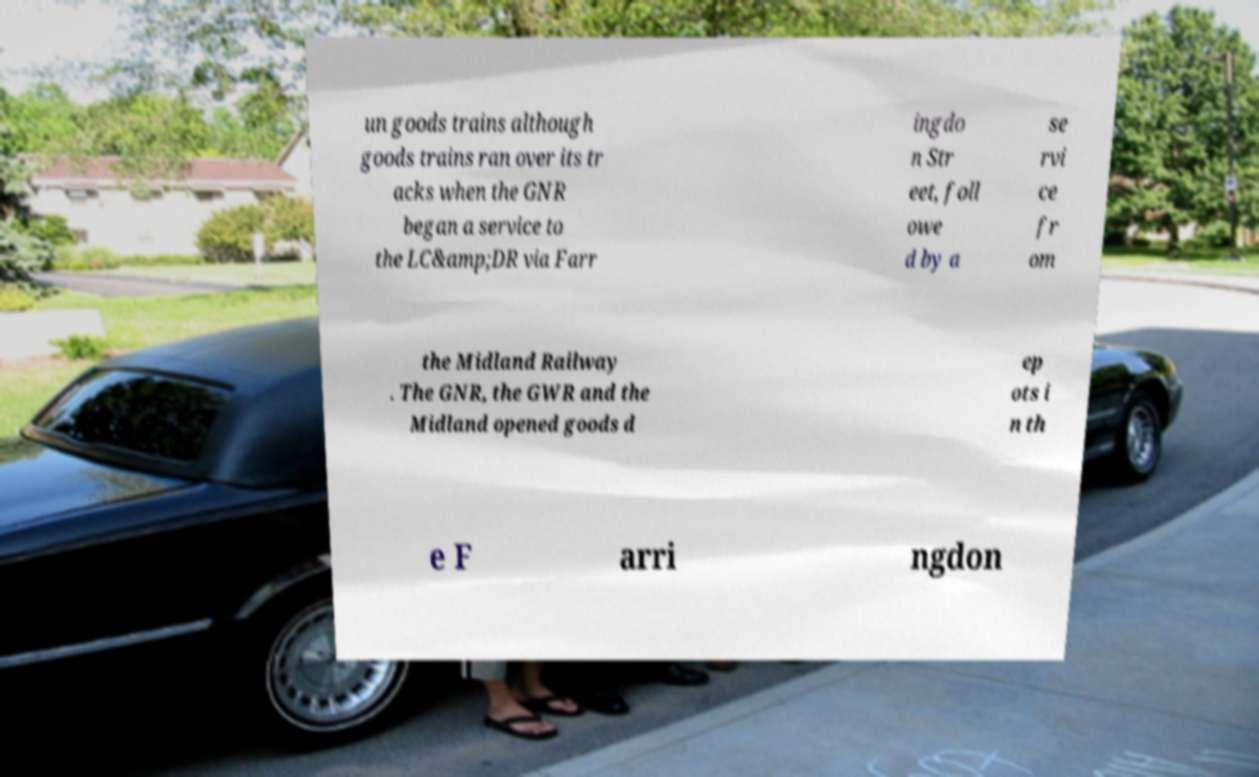Could you extract and type out the text from this image? un goods trains although goods trains ran over its tr acks when the GNR began a service to the LC&amp;DR via Farr ingdo n Str eet, foll owe d by a se rvi ce fr om the Midland Railway . The GNR, the GWR and the Midland opened goods d ep ots i n th e F arri ngdon 